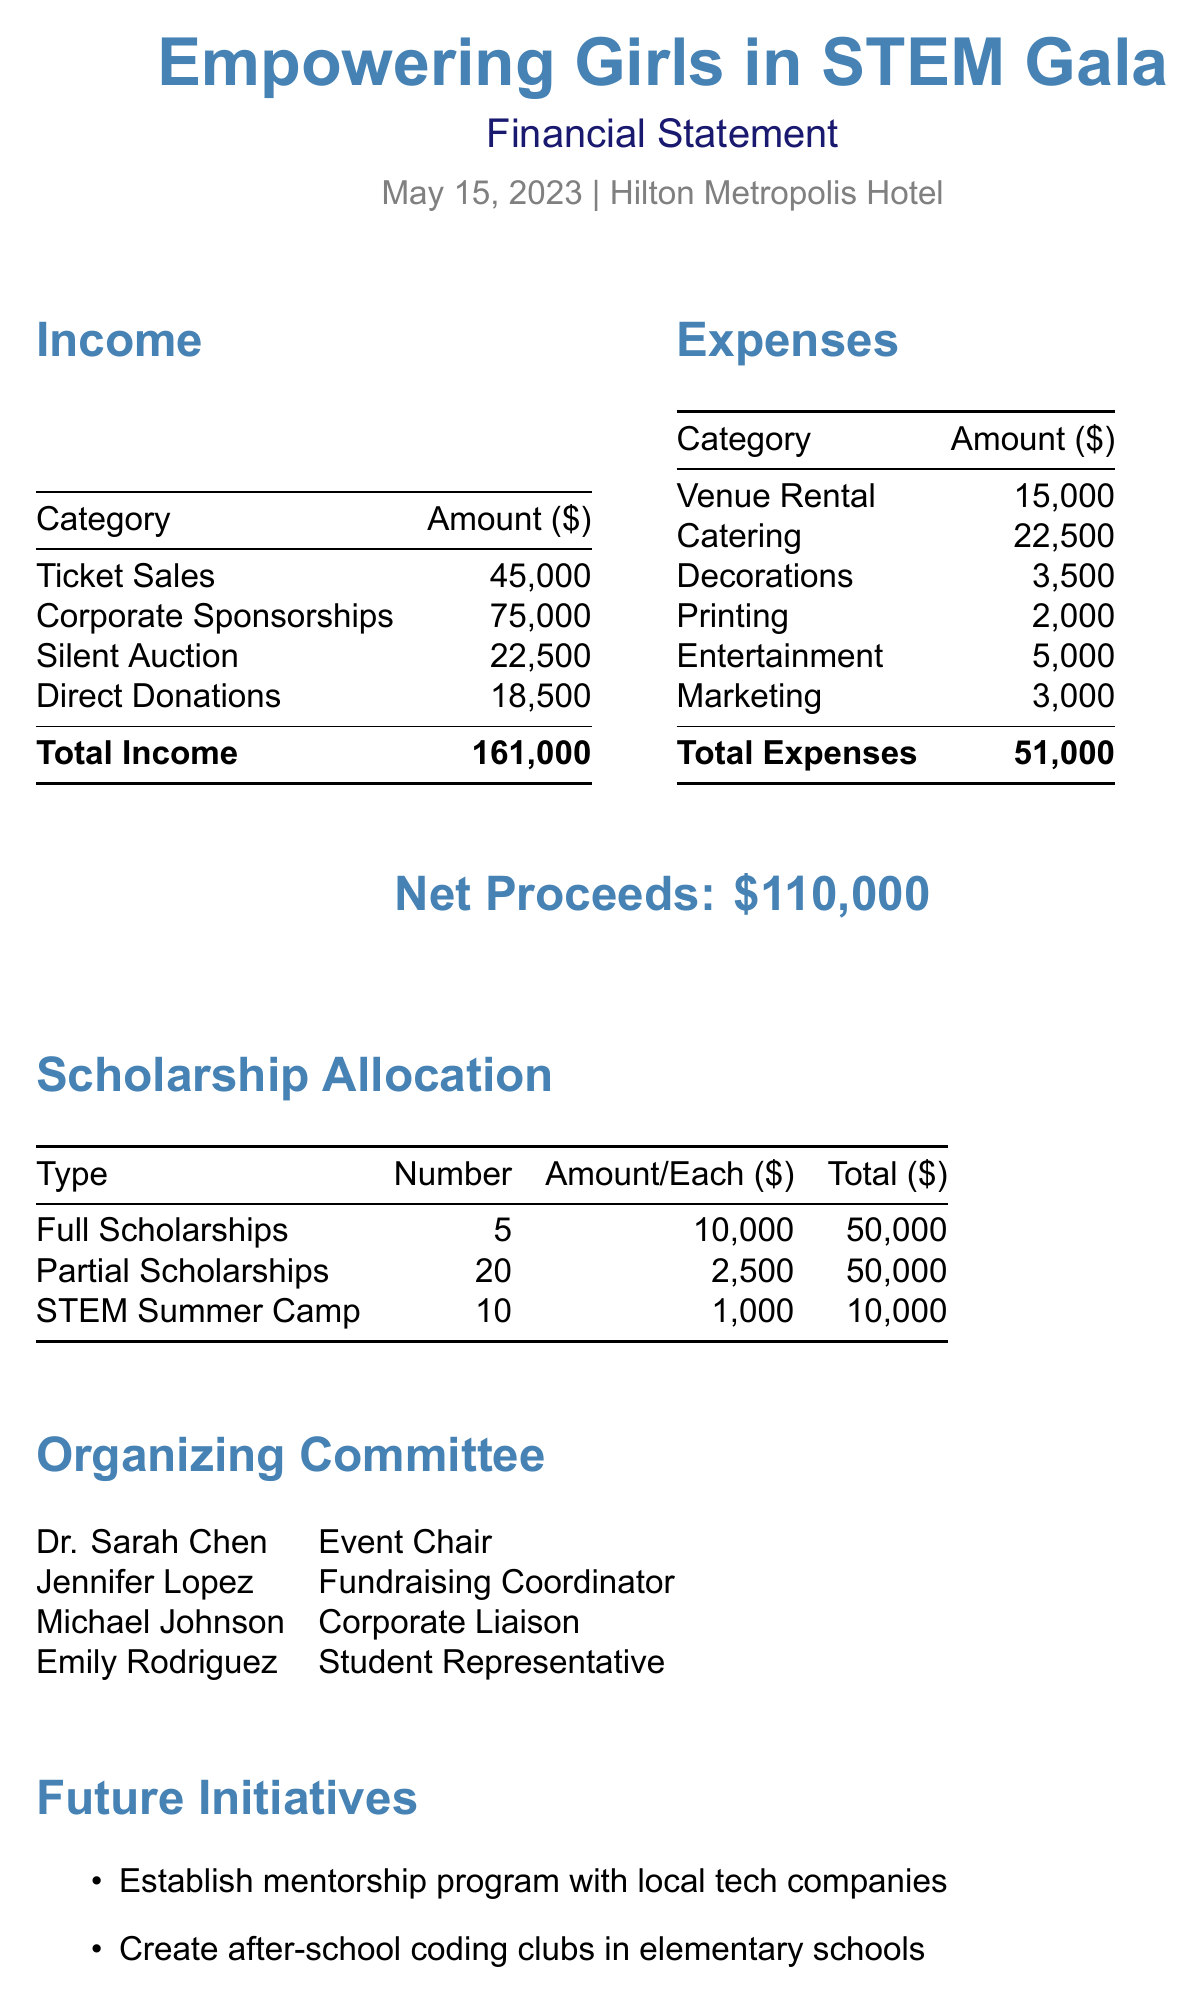what was the total income from ticket sales? The total income from ticket sales is $45,000, as specified in the income section of the document.
Answer: $45,000 who was the event chair? The event chair is Dr. Sarah Chen, mentioned in the organizing committee section.
Answer: Dr. Sarah Chen what is the total amount allocated for full scholarships? The total amount allocated for full scholarships is $50,000, as provided in the scholarship allocation section.
Answer: $50,000 how many partial scholarships are there? There are 20 partial scholarships, which is listed in the scholarship allocation table.
Answer: 20 what is the location of the gala? The location of the gala is Hilton Metropolis Hotel, indicated at the top of the document.
Answer: Hilton Metropolis Hotel what was the total expense amount? The total expense amount is $51,000, calculated from the expenses listed in the document.
Answer: $51,000 how many total net proceeds were raised? The total net proceeds raised were $110,000, explicitly stated in the document.
Answer: $110,000 what type of sponsorships were provided by corporate partners? The document refers to corporate sponsorships, including gold and silver sponsors, which capture the support from companies.
Answer: Corporate Sponsorships how many items were donated for the silent auction? The silent auction had a total of 25 items donated, as mentioned in the income section.
Answer: 25 